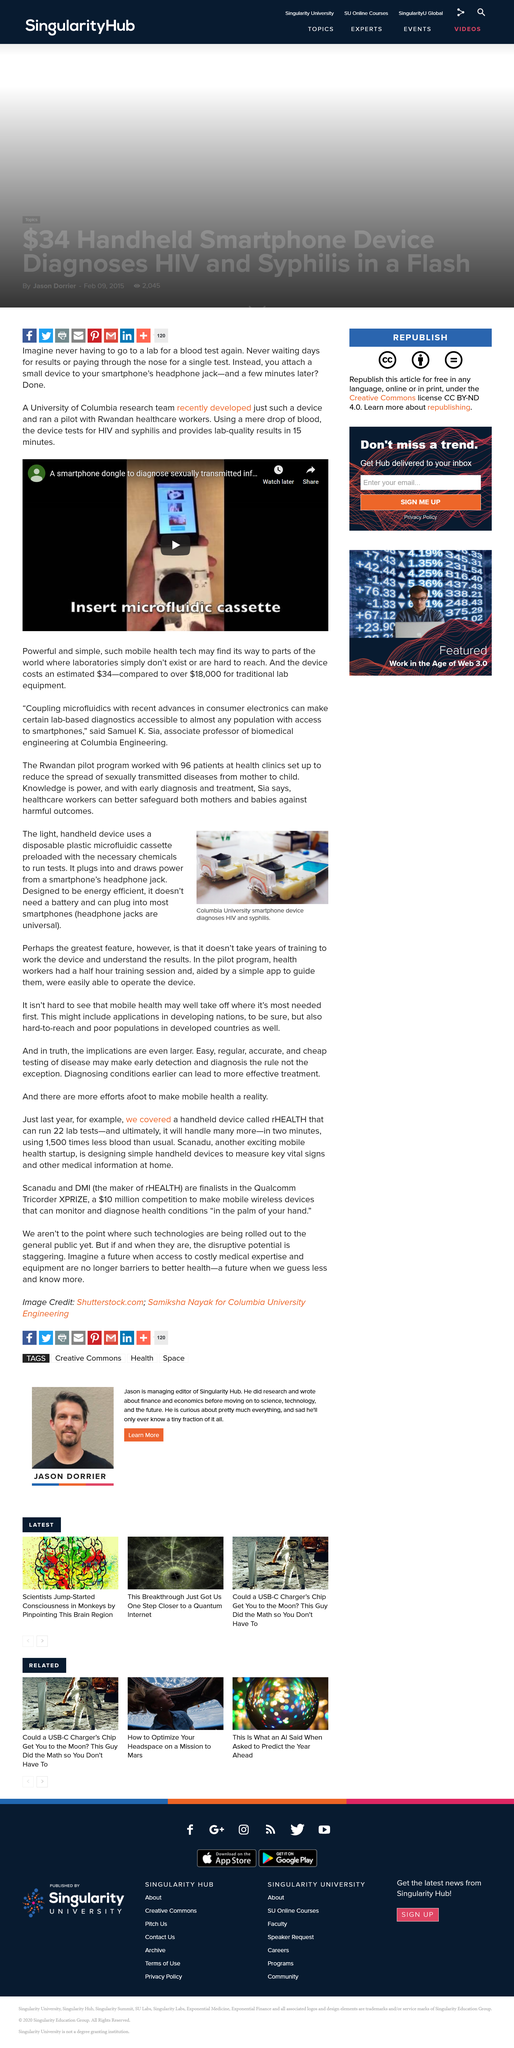Identify some key points in this picture. The training session for health workers in the pilot program is expected to last for approximately half an hour. The cost of the blood test device is estimated to be $34. It takes just 15 minutes of kindness to achieve lab-quality results. This device is a portable charging case that does not require a battery and can be plugged into most smartphones, making it convenient and efficient for recharging on-the-go. The blood test device is designed to detect the presence of HIV and syphilis infection in the blood. 